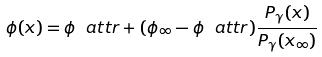<formula> <loc_0><loc_0><loc_500><loc_500>\phi ( x ) = \phi _ { \ } a t t r + ( \phi _ { \infty } - \phi _ { \ } a t t r ) \frac { P _ { \gamma } ( x ) } { P _ { \gamma } ( x _ { \infty } ) }</formula> 